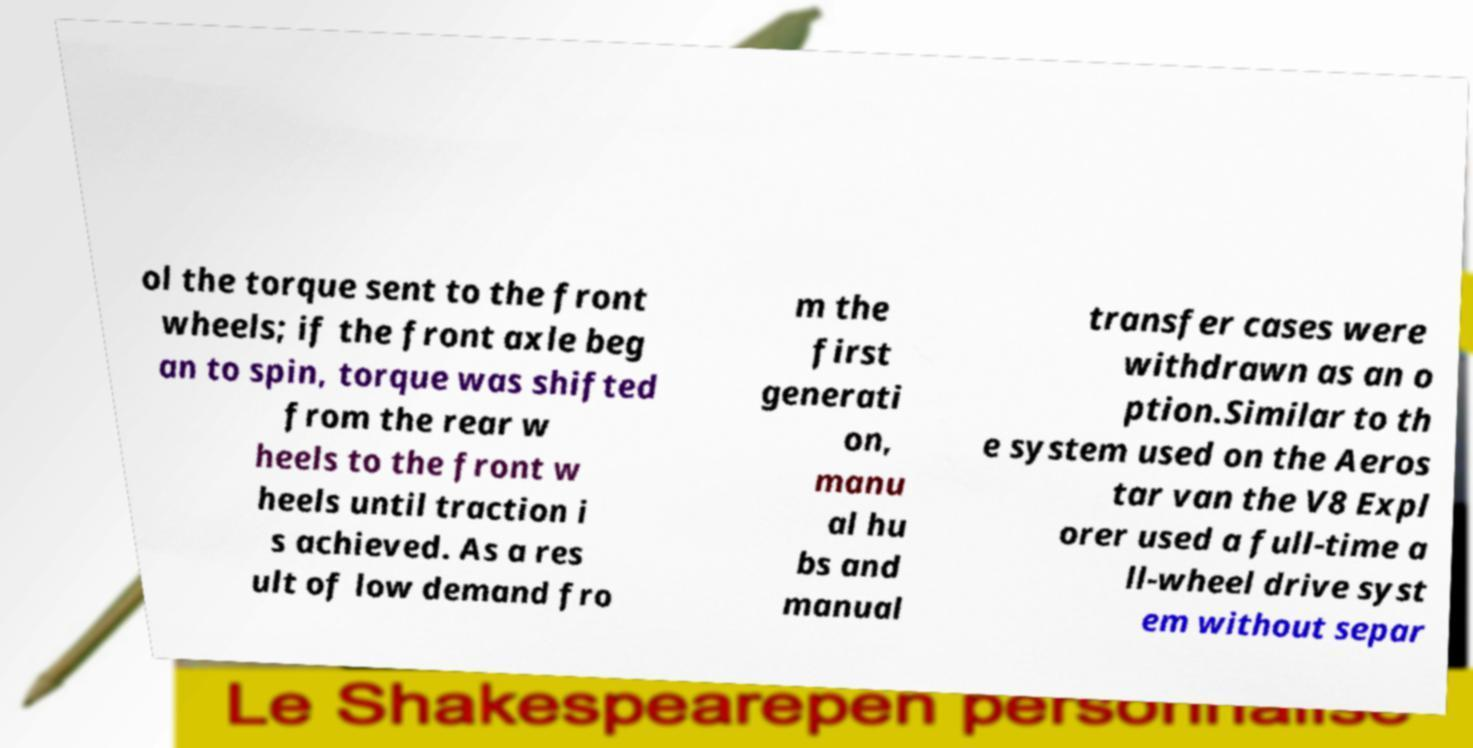Please read and relay the text visible in this image. What does it say? ol the torque sent to the front wheels; if the front axle beg an to spin, torque was shifted from the rear w heels to the front w heels until traction i s achieved. As a res ult of low demand fro m the first generati on, manu al hu bs and manual transfer cases were withdrawn as an o ption.Similar to th e system used on the Aeros tar van the V8 Expl orer used a full-time a ll-wheel drive syst em without separ 